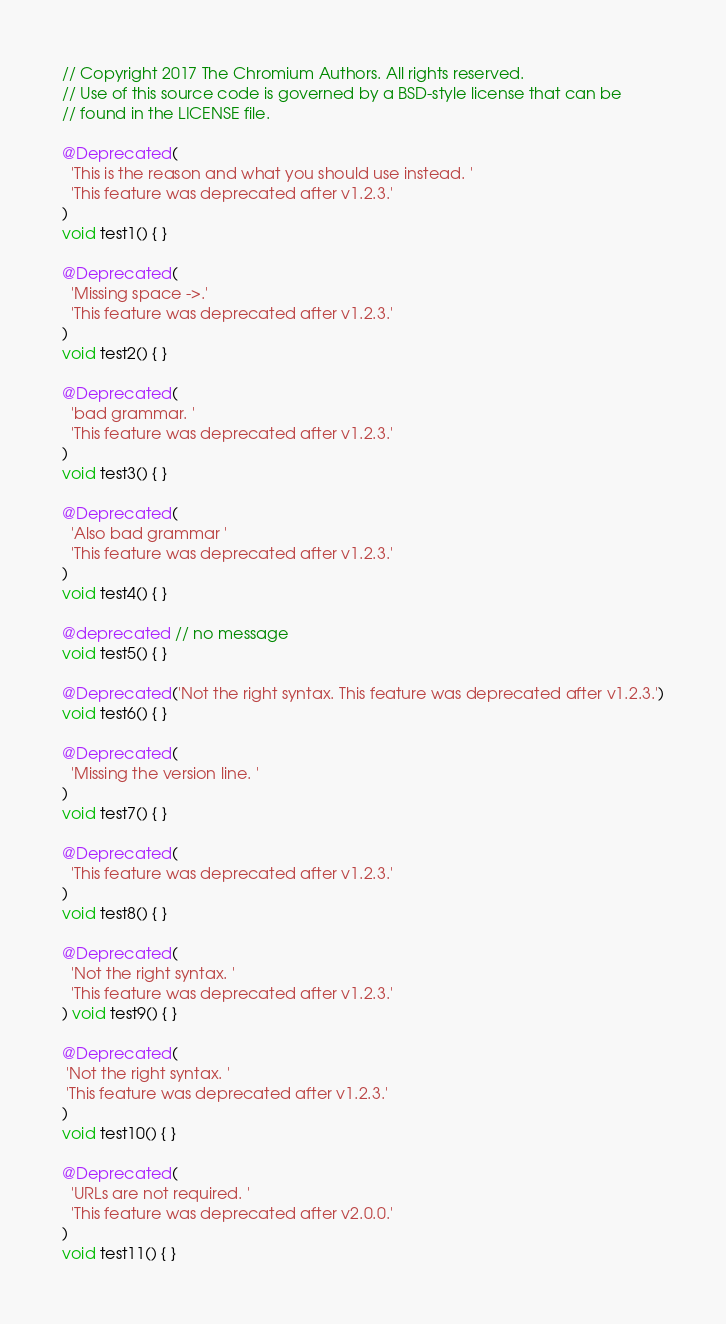<code> <loc_0><loc_0><loc_500><loc_500><_Dart_>// Copyright 2017 The Chromium Authors. All rights reserved.
// Use of this source code is governed by a BSD-style license that can be
// found in the LICENSE file.

@Deprecated(
  'This is the reason and what you should use instead. '
  'This feature was deprecated after v1.2.3.'
)
void test1() { }

@Deprecated(
  'Missing space ->.'
  'This feature was deprecated after v1.2.3.'
)
void test2() { }

@Deprecated(
  'bad grammar. '
  'This feature was deprecated after v1.2.3.'
)
void test3() { }

@Deprecated(
  'Also bad grammar '
  'This feature was deprecated after v1.2.3.'
)
void test4() { }

@deprecated // no message
void test5() { }

@Deprecated('Not the right syntax. This feature was deprecated after v1.2.3.')
void test6() { }

@Deprecated(
  'Missing the version line. '
)
void test7() { }

@Deprecated(
  'This feature was deprecated after v1.2.3.'
)
void test8() { }

@Deprecated(
  'Not the right syntax. '
  'This feature was deprecated after v1.2.3.'
) void test9() { }

@Deprecated(
 'Not the right syntax. '
 'This feature was deprecated after v1.2.3.'
)
void test10() { }

@Deprecated(
  'URLs are not required. '
  'This feature was deprecated after v2.0.0.'
)
void test11() { }
</code> 